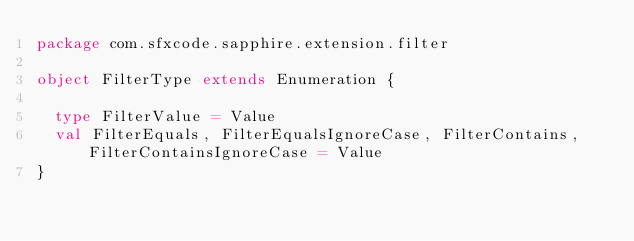Convert code to text. <code><loc_0><loc_0><loc_500><loc_500><_Scala_>package com.sfxcode.sapphire.extension.filter

object FilterType extends Enumeration {

  type FilterValue = Value
  val FilterEquals, FilterEqualsIgnoreCase, FilterContains, FilterContainsIgnoreCase = Value
}
</code> 